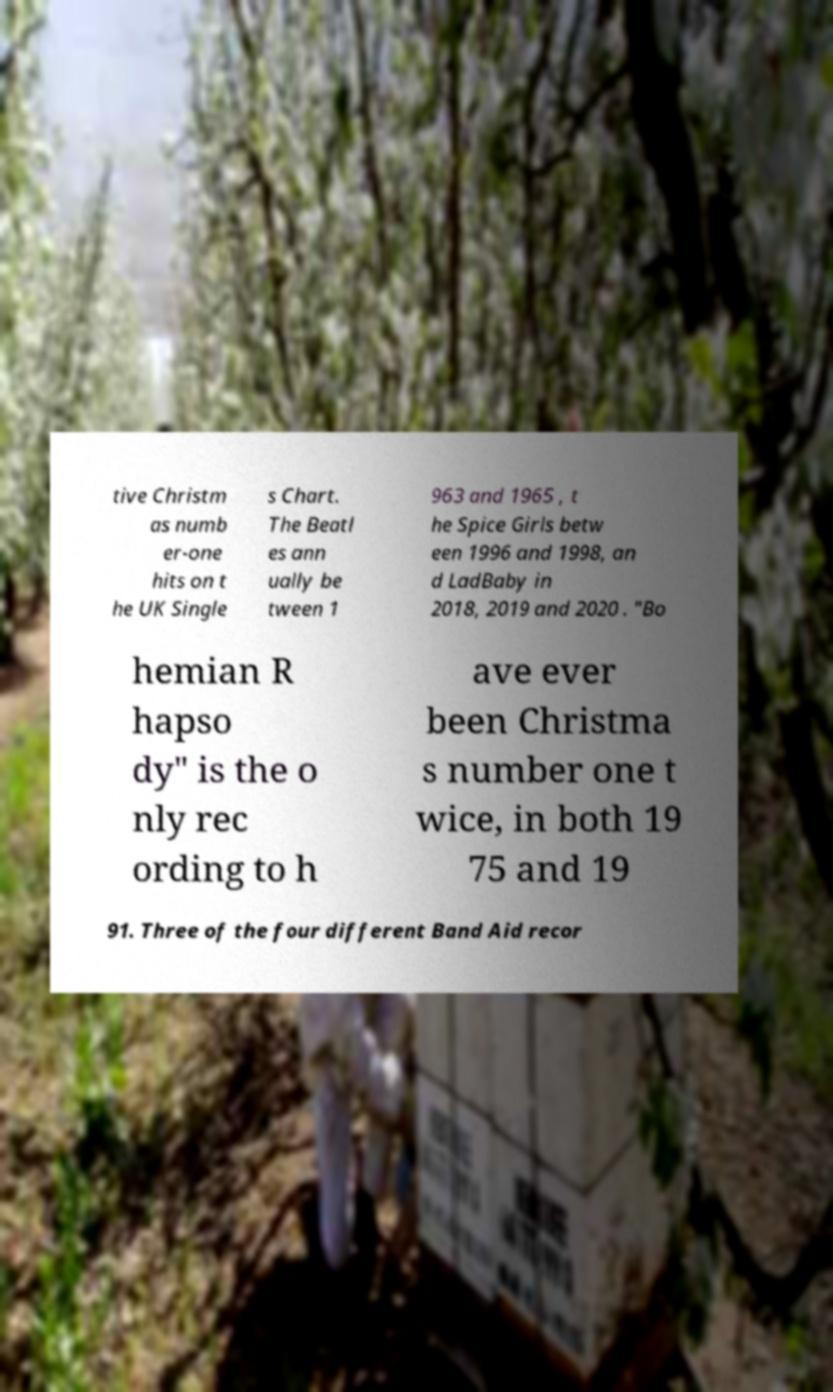Please identify and transcribe the text found in this image. tive Christm as numb er-one hits on t he UK Single s Chart. The Beatl es ann ually be tween 1 963 and 1965 , t he Spice Girls betw een 1996 and 1998, an d LadBaby in 2018, 2019 and 2020 . "Bo hemian R hapso dy" is the o nly rec ording to h ave ever been Christma s number one t wice, in both 19 75 and 19 91. Three of the four different Band Aid recor 